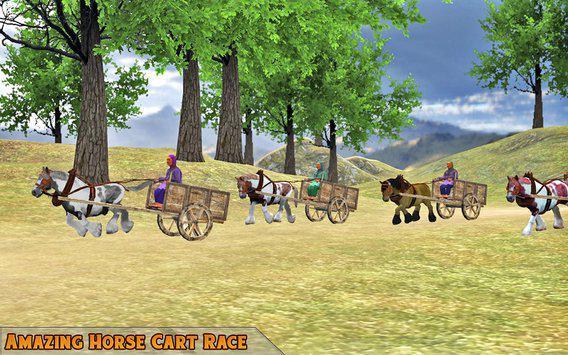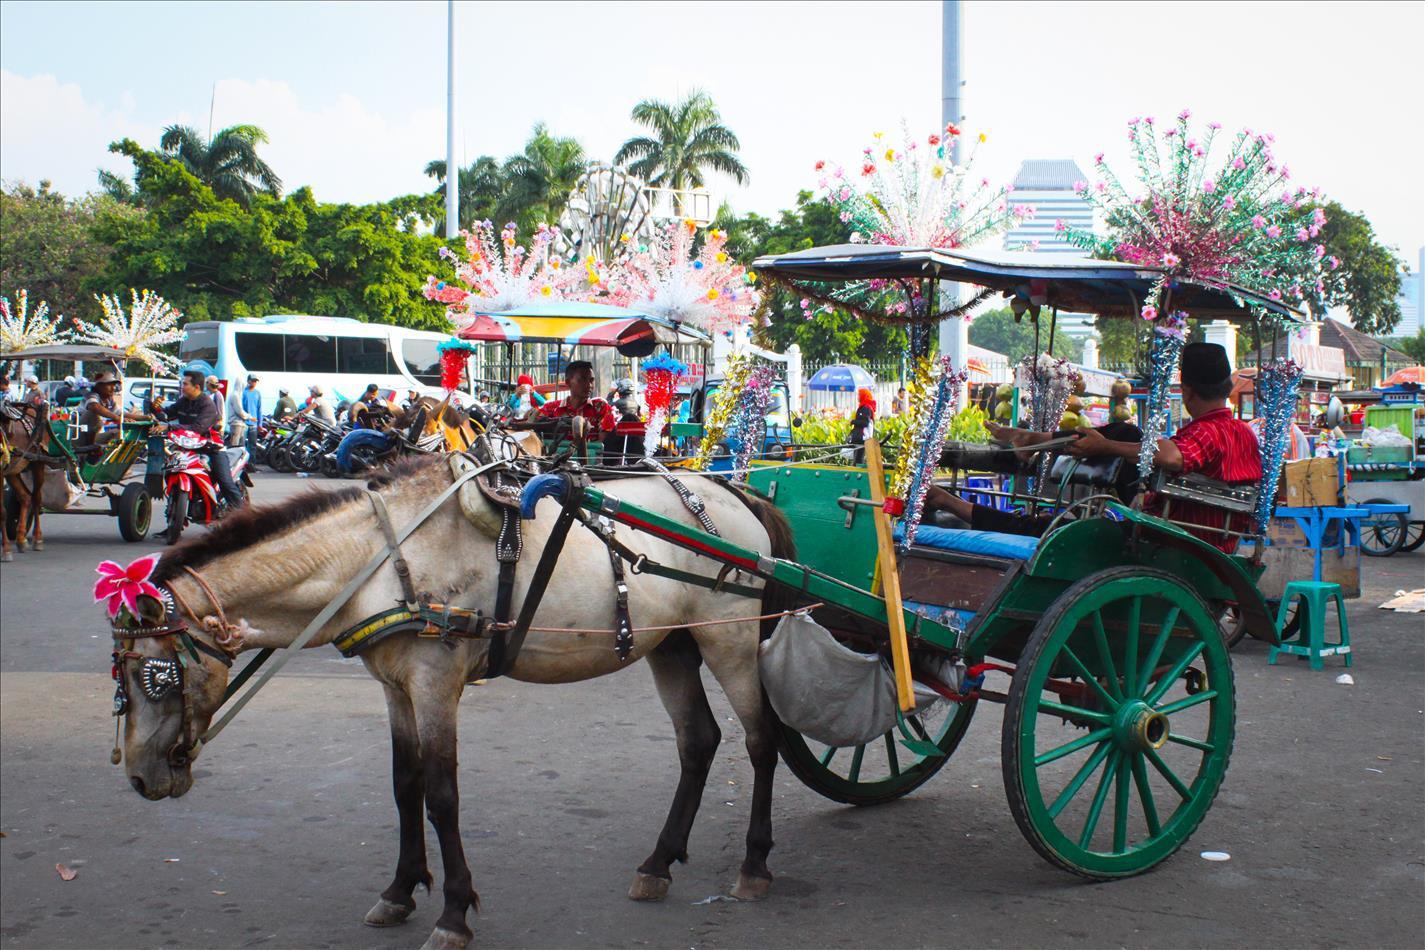The first image is the image on the left, the second image is the image on the right. Given the left and right images, does the statement "An image shows a leftward-turned horse standing still with lowered head and hitched to a two-wheeled cart with a canopy top." hold true? Answer yes or no. Yes. The first image is the image on the left, the second image is the image on the right. Given the left and right images, does the statement "The left and right image contains the same number of horses pulling a cart." hold true? Answer yes or no. No. 